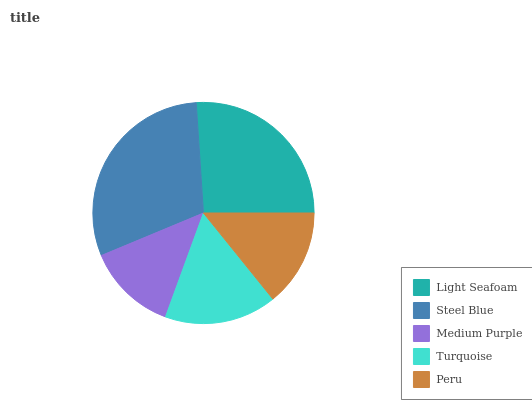Is Medium Purple the minimum?
Answer yes or no. Yes. Is Steel Blue the maximum?
Answer yes or no. Yes. Is Steel Blue the minimum?
Answer yes or no. No. Is Medium Purple the maximum?
Answer yes or no. No. Is Steel Blue greater than Medium Purple?
Answer yes or no. Yes. Is Medium Purple less than Steel Blue?
Answer yes or no. Yes. Is Medium Purple greater than Steel Blue?
Answer yes or no. No. Is Steel Blue less than Medium Purple?
Answer yes or no. No. Is Turquoise the high median?
Answer yes or no. Yes. Is Turquoise the low median?
Answer yes or no. Yes. Is Light Seafoam the high median?
Answer yes or no. No. Is Steel Blue the low median?
Answer yes or no. No. 